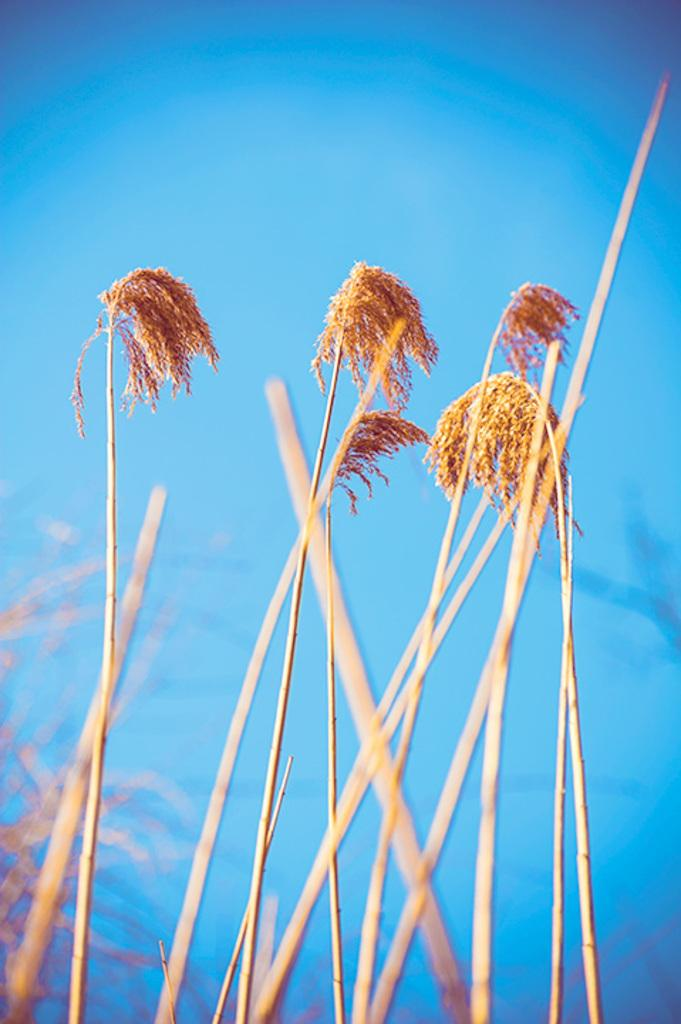What type of plant elements can be seen in the image? There are stems and leaves in the image. Where are the stems and leaves located in the image? The stems and leaves are in the middle of the image. What color is the sky in the background of the image? The sky is blue in the background of the image. How many cattle are present in the image? There are no cattle present in the image; it only features stems and leaves. What is the front of the image showing? The front of the image is not mentioned in the provided facts, so we cannot determine what it shows. 